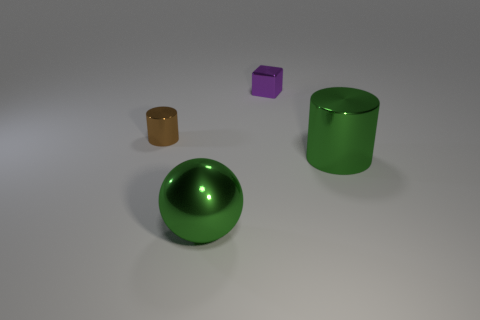Is there a small purple thing?
Provide a short and direct response. Yes. The cylinder that is right of the large green ball is what color?
Keep it short and to the point. Green. There is a purple cube; is it the same size as the thing that is left of the big metallic sphere?
Give a very brief answer. Yes. How big is the thing that is behind the large cylinder and right of the tiny brown cylinder?
Make the answer very short. Small. Is there a small blue sphere made of the same material as the purple thing?
Ensure brevity in your answer.  No. There is a tiny purple metal object; what shape is it?
Your answer should be very brief. Cube. Is the size of the purple block the same as the brown metallic thing?
Offer a very short reply. Yes. What number of other things are the same shape as the purple thing?
Give a very brief answer. 0. There is a tiny object to the right of the small brown metal cylinder; what shape is it?
Give a very brief answer. Cube. There is a tiny object that is on the left side of the purple metallic thing; is its shape the same as the big object in front of the large green metallic cylinder?
Offer a very short reply. No. 